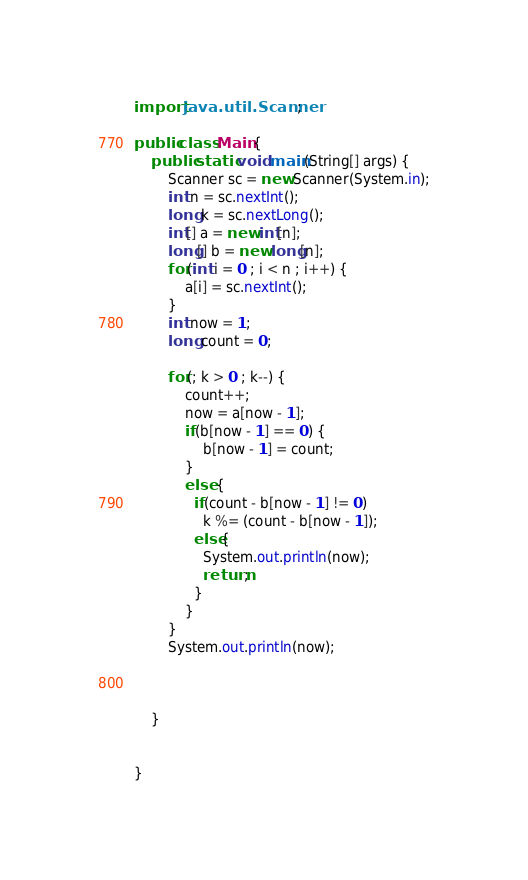Convert code to text. <code><loc_0><loc_0><loc_500><loc_500><_Java_>import java.util.Scanner;

public class Main {
	public static void main(String[] args) {
		Scanner sc = new Scanner(System.in);
		int n = sc.nextInt();
		long k = sc.nextLong();
		int[] a = new int[n];
		long[] b = new long[n];
		for(int i = 0 ; i < n ; i++) {
			a[i] = sc.nextInt();
		}
		int now = 1;
		long count = 0;

		for(; k > 0 ; k--) {
			count++;
			now = a[now - 1];
			if(b[now - 1] == 0) {
				b[now - 1] = count;
			}
			else {
              if(count - b[now - 1] != 0)
				k %= (count - b[now - 1]);
              else{
                System.out.println(now);
                return;
              }
			}
		}
		System.out.println(now);



	}


}

</code> 